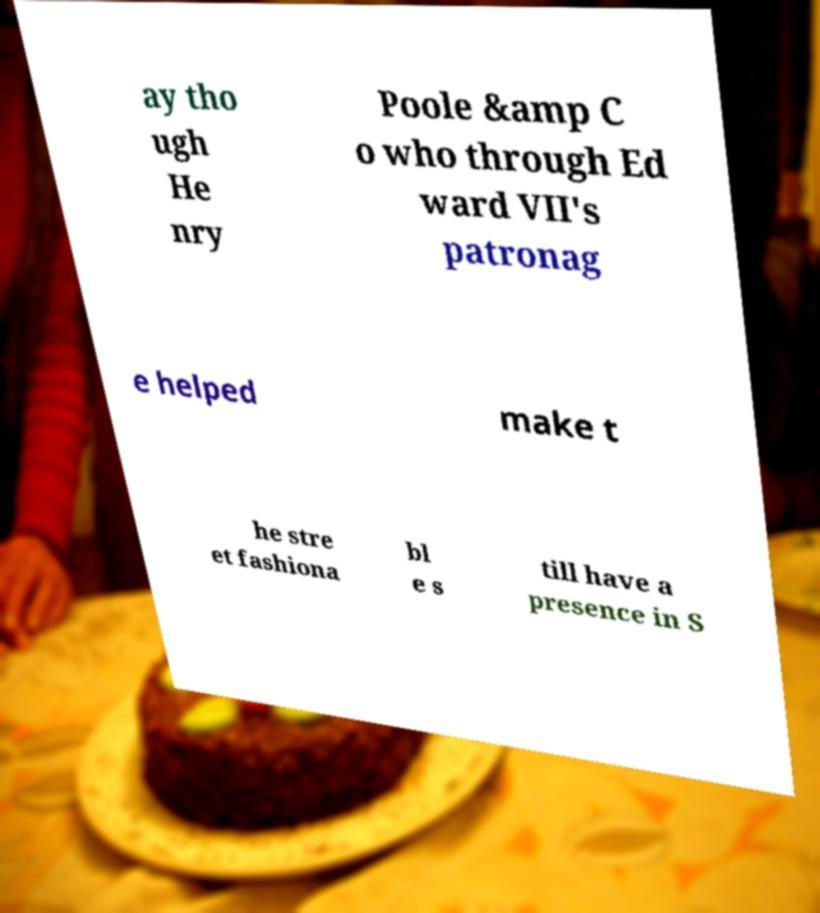For documentation purposes, I need the text within this image transcribed. Could you provide that? ay tho ugh He nry Poole &amp C o who through Ed ward VII's patronag e helped make t he stre et fashiona bl e s till have a presence in S 